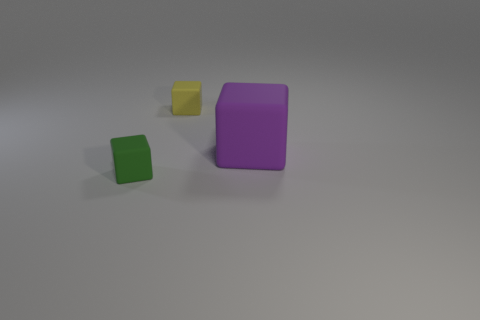If these objects were part of a larger set, what additional items might you expect to find with them? If these are part of a set, one might expect to find other geometric shapes in various colors and sizes, possibly including spheres, cylinders, or pyramids, which together could be used for educational purposes or as a set of building blocks for creative play. 